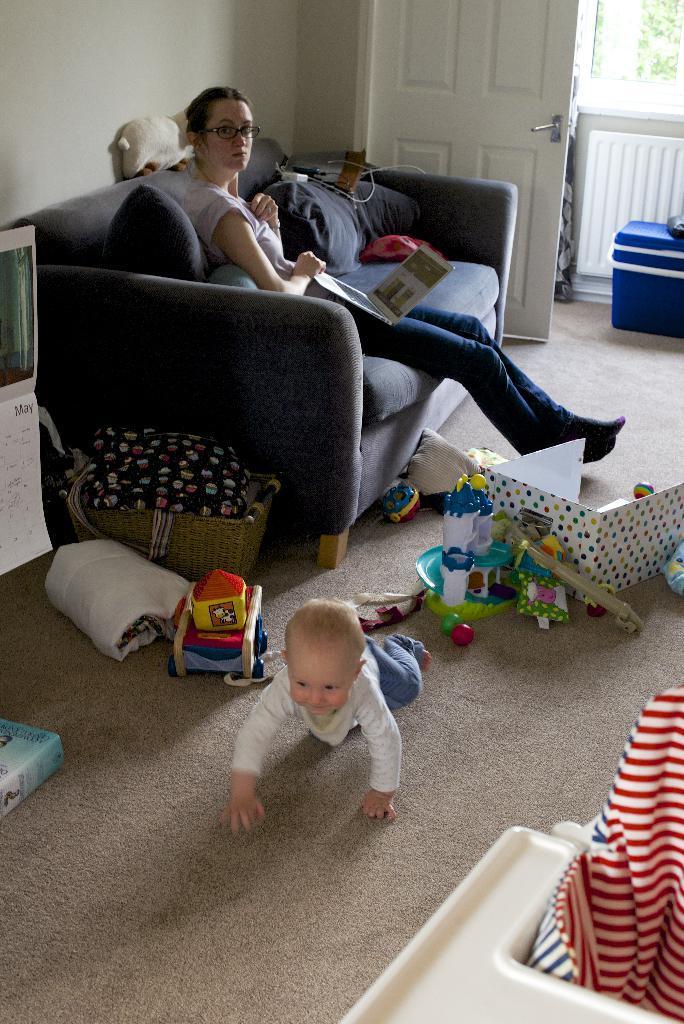Please provide a concise description of this image. It is a room inside the house, a baby is crawling on the floor, there are some toys around the baby and also a basket behind the baby, beside the basket there is a grey color sofa a woman is sitting on sofa and she is holding a laptop in her hand. There is a calendar left side to the sofa and door right side to the sofa in the background there is a balcony, a box of blue color and some trees. 